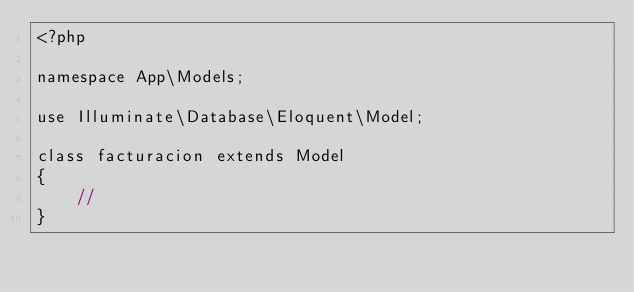<code> <loc_0><loc_0><loc_500><loc_500><_PHP_><?php

namespace App\Models;

use Illuminate\Database\Eloquent\Model;

class facturacion extends Model
{
    //
}
</code> 